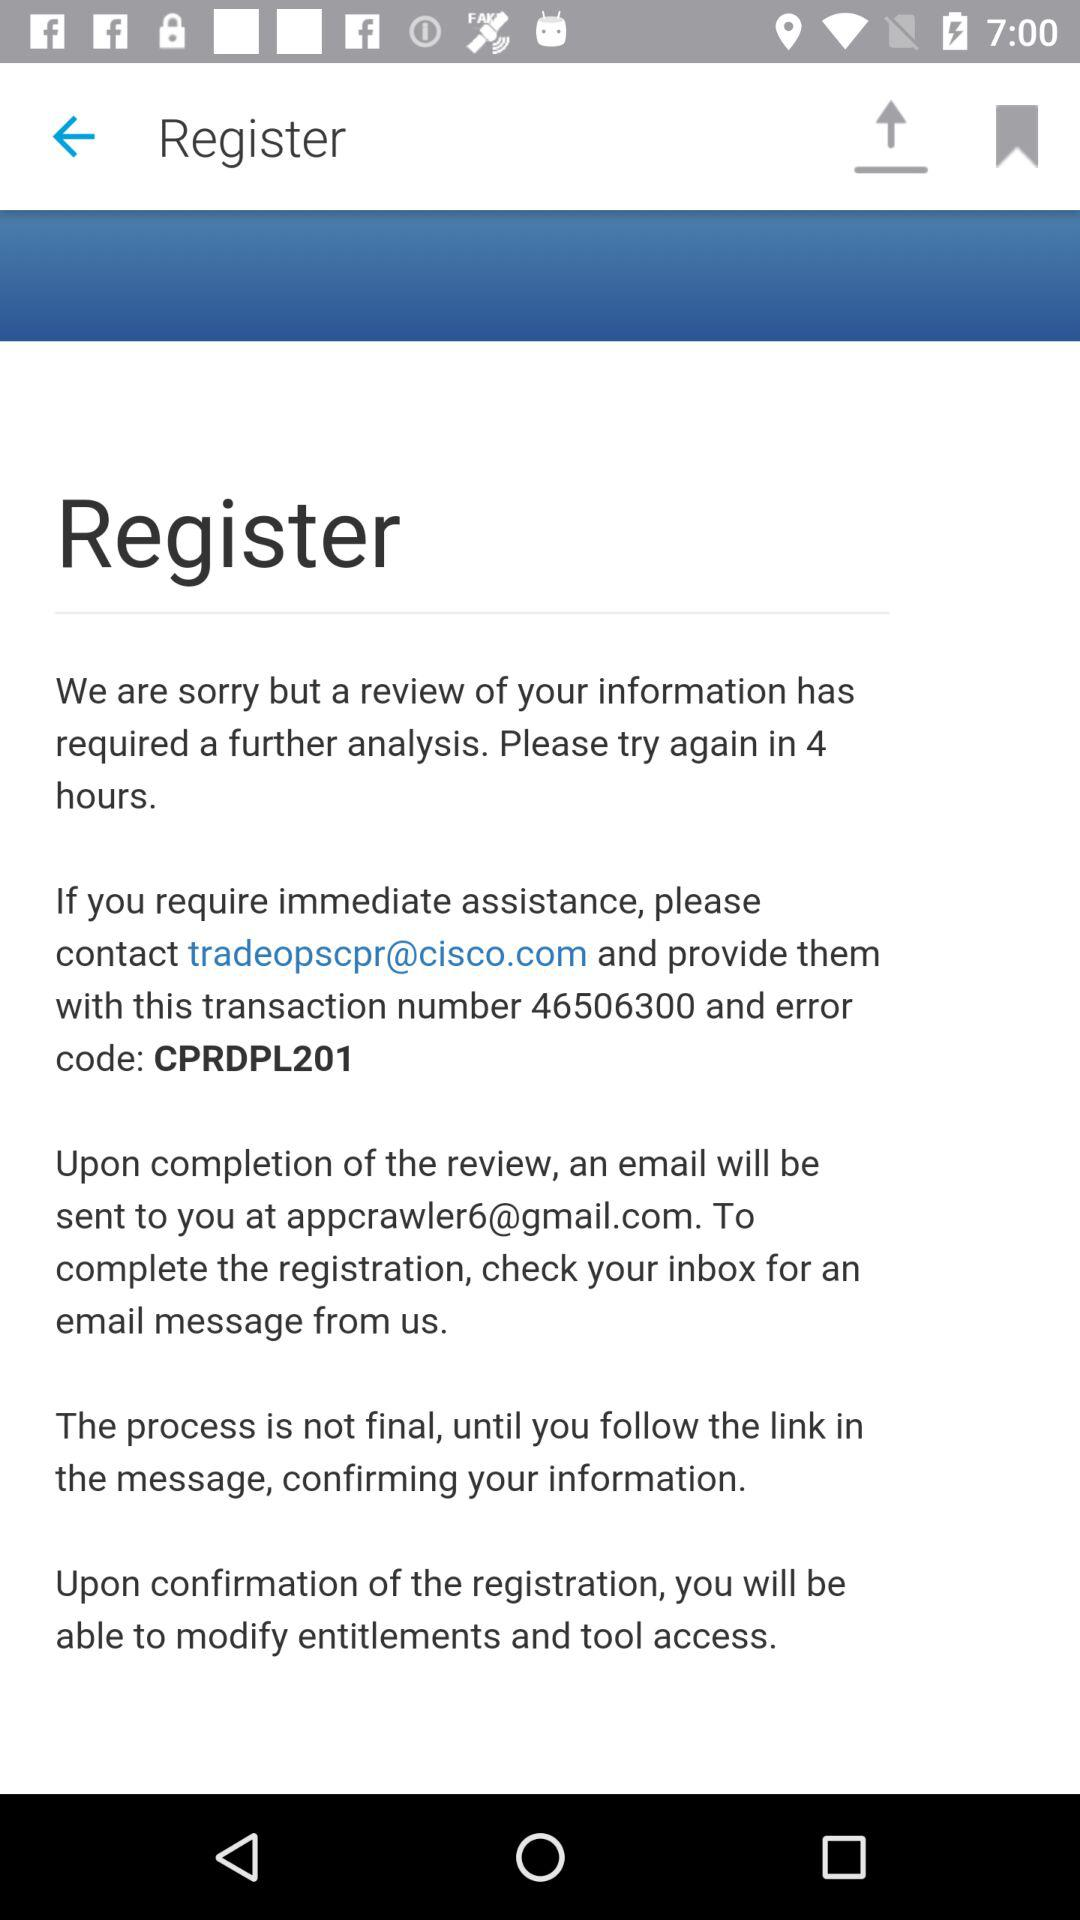What is the transaction number? The transaction number is 46506300. 